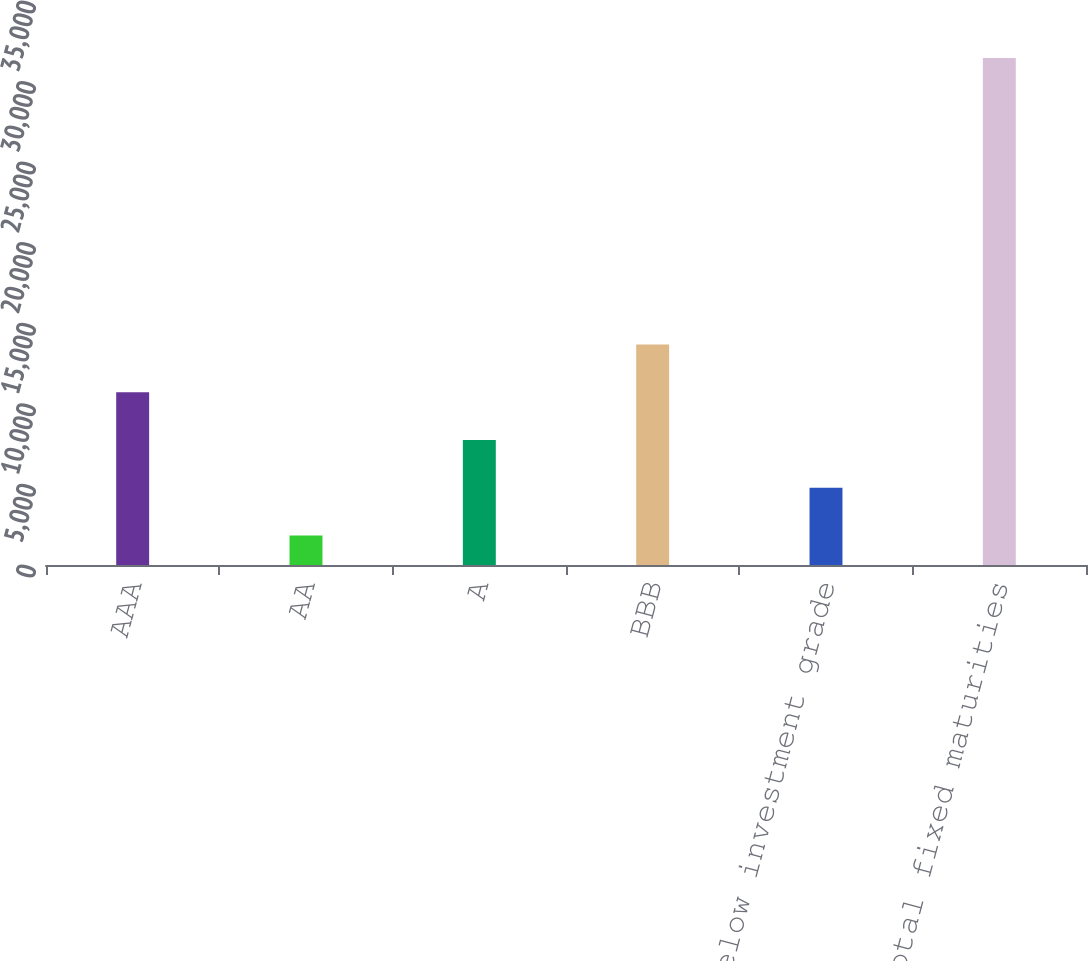Convert chart. <chart><loc_0><loc_0><loc_500><loc_500><bar_chart><fcel>AAA<fcel>AA<fcel>A<fcel>BBB<fcel>Below investment grade<fcel>Total fixed maturities<nl><fcel>10716.6<fcel>1827<fcel>7753.4<fcel>13679.8<fcel>4790.2<fcel>31459<nl></chart> 